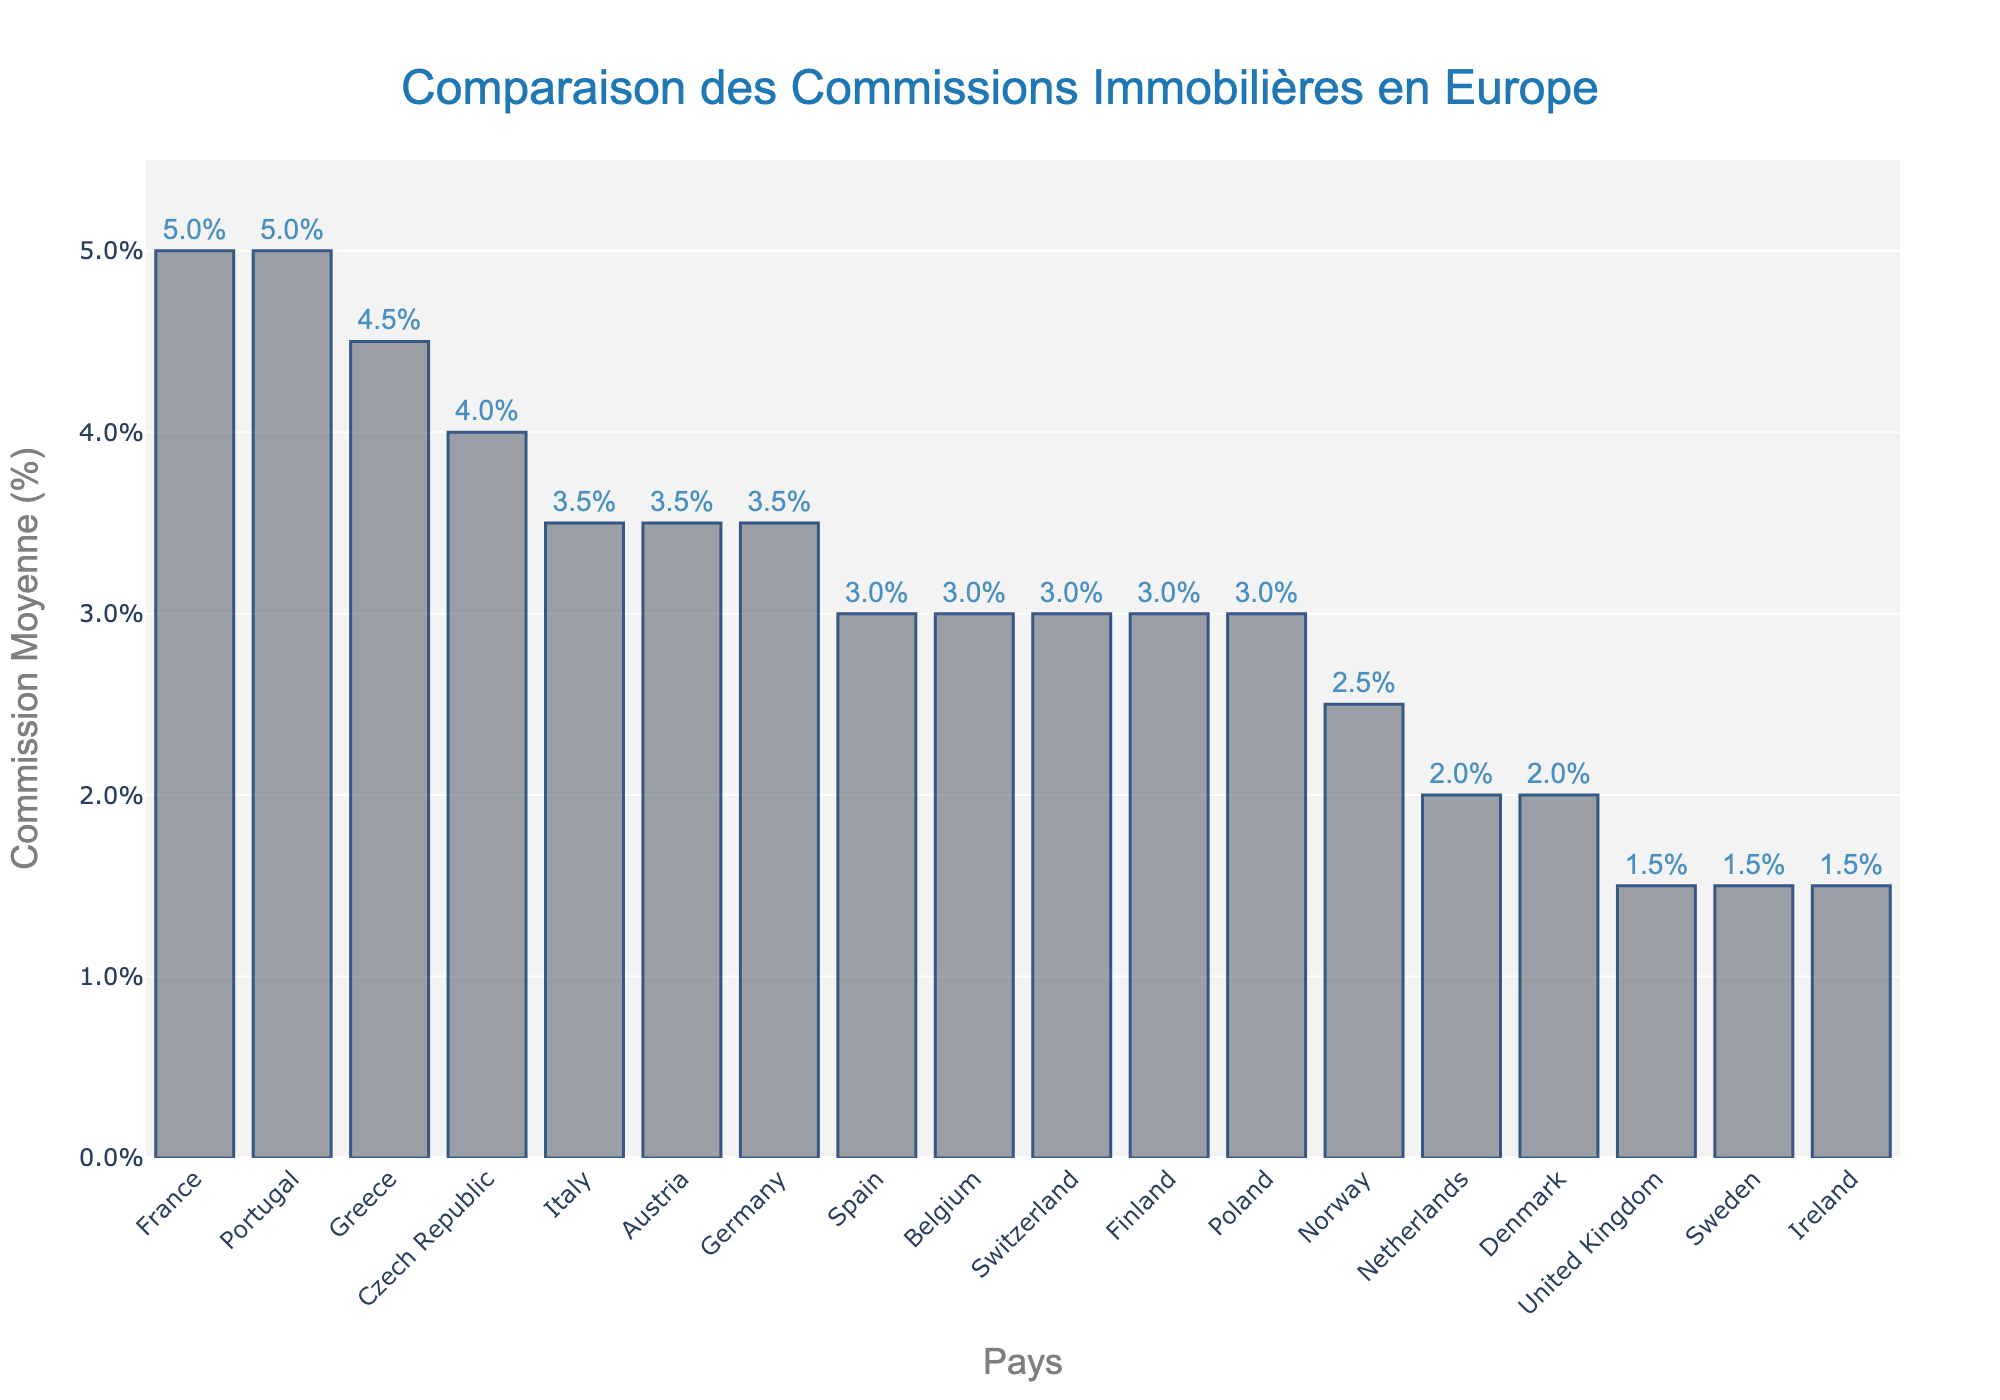What country has the highest average real estate commission? Look at the bar with the greatest height. France and Portugal have the highest bars, each at 5.0%.
Answer: France and Portugal Which country has the lowest average commission, and what is the value? Identify the shortest bar. The United Kingdom, Sweden, and Ireland all share the shortest bar at 1.5%.
Answer: United Kingdom, Sweden, and Ireland at 1.5% How much higher is France’s commission compared to Germany’s? Find the difference in height between France’s and Germany’s bars. France is at 5.0% and Germany is at 3.5%. Calculate the difference: 5.0% - 3.5% = 1.5%.
Answer: 1.5% Which countries have an average commission higher than 4%? Look for bars higher than the 4% mark on the y-axis. France, Portugal, Greece, and Czech Republic have bars higher than 4%.
Answer: France, Portugal, Greece, and Czech Republic Among Spain, Italy, and Belgium, which has the highest commission, and how much is it? Compare the bars of Spain, Italy, and Belgium. They are the same at 3.0%.
Answer: They are all the same at 3.0% What's the average commission percentage across all the countries? Sum up the commission percentages and divide by the number of countries. (5.0 + 3.5 + 1.5 + 3.0 + 3.5 + 2.0 + 3.0 + 3.0 + 3.5 + 5.0 + 1.5 + 2.0 + 2.5 + 3.0 + 3.0 + 4.0 + 4.5 + 1.5) / 18 = 3.06%.
Answer: 3.06% Which country between Norway and Denmark has a lower commission and by how much? Compare the heights of the bars for Norway and Denmark. Norway's bar is at 2.5% and Denmark's bar is at 2.0%. The difference is 2.5% - 2.0% = 0.5%.
Answer: Denmark by 0.5% If you combine the commissions of Italy and Finland, what is the total commission percentage? Sum the values for Italy and Finland. Italy is at 3.5% and Finland is at 3.0%. 3.5% + 3.0% = 6.5%.
Answer: 6.5% How does the average commission in France compare to the Netherlands? France's bar is taller at 5.0%, while Netherlands is at 2.0%. Compare the heights to find that France has a higher commission.
Answer: France has a higher commission Which countries have exactly a 3% commission? Look at the bars at the 3.0% mark. Spain, Belgium, Switzerland, Finland, and Poland all have this value.
Answer: Spain, Belgium, Switzerland, Finland, and Poland 